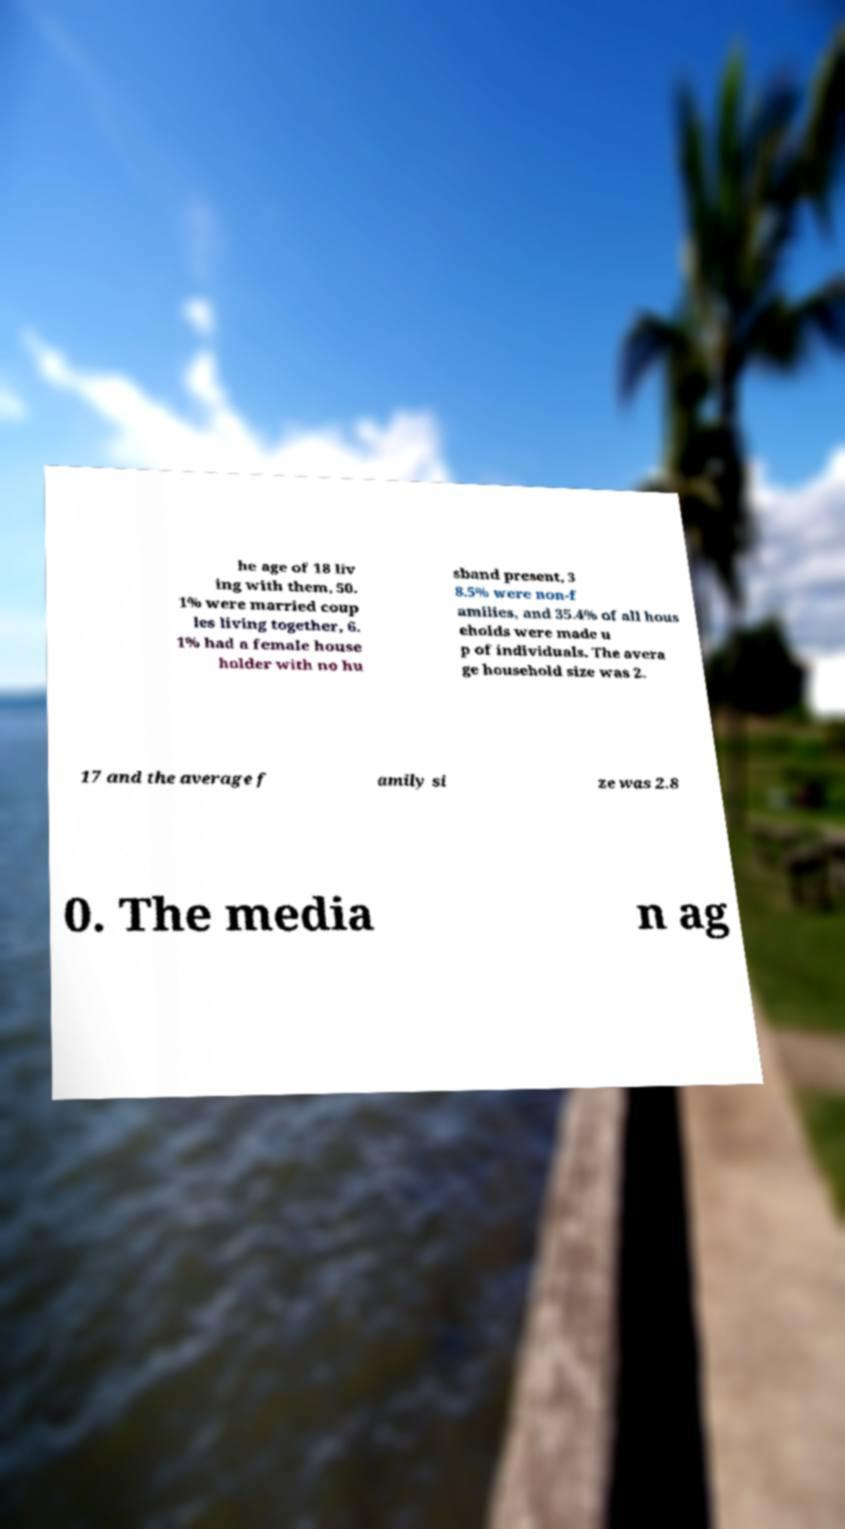Could you extract and type out the text from this image? he age of 18 liv ing with them, 50. 1% were married coup les living together, 6. 1% had a female house holder with no hu sband present, 3 8.5% were non-f amilies, and 35.4% of all hous eholds were made u p of individuals. The avera ge household size was 2. 17 and the average f amily si ze was 2.8 0. The media n ag 